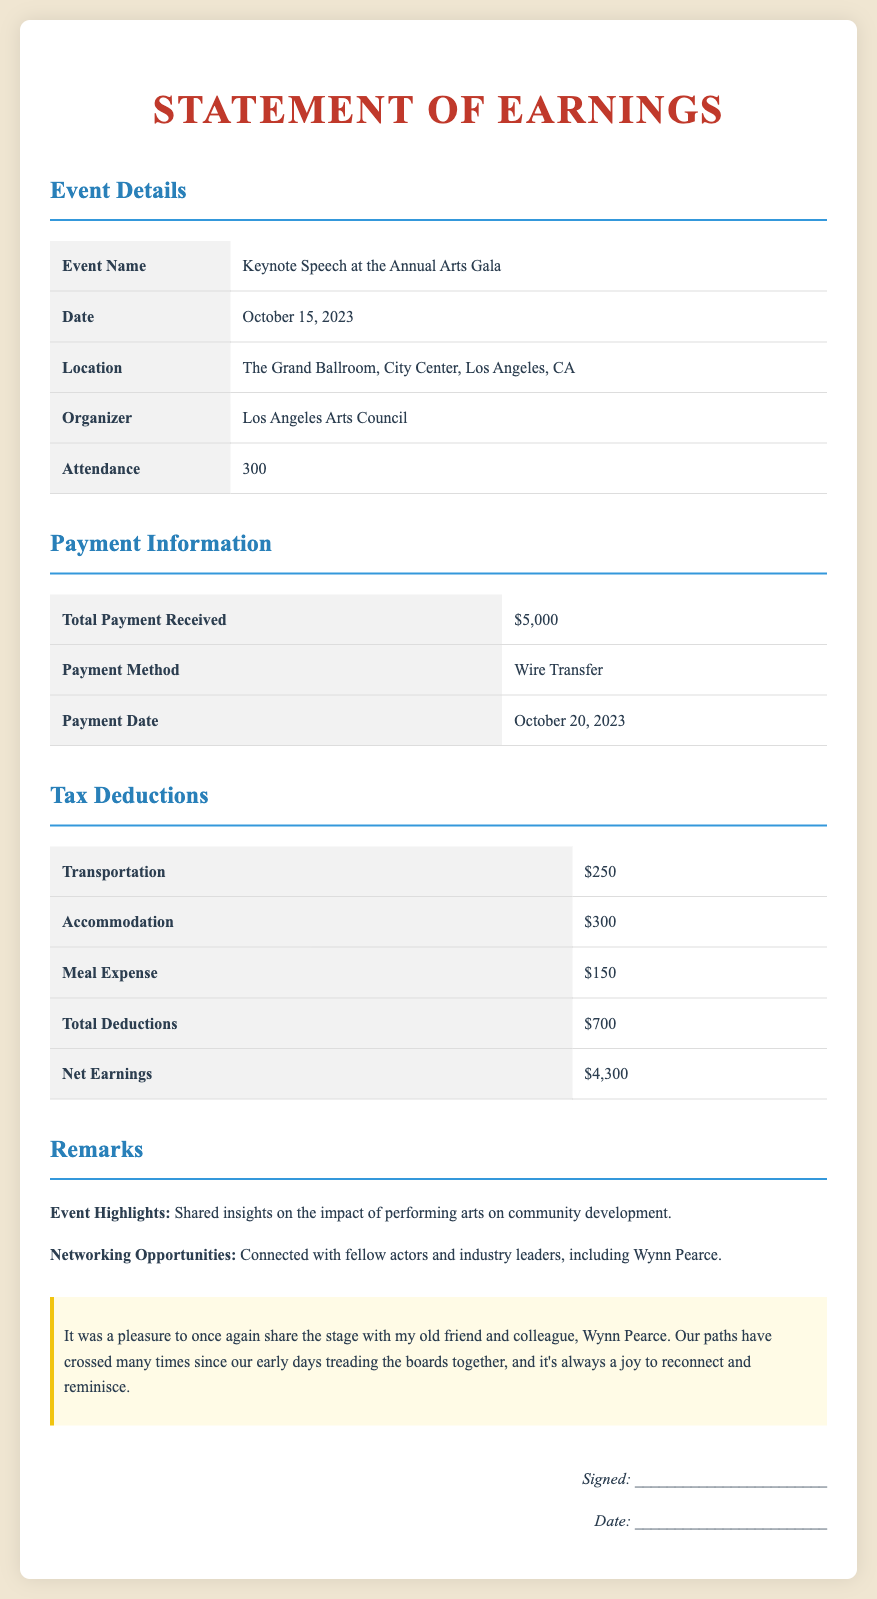what was the event name? The event name is clearly stated in the event details section of the document.
Answer: Keynote Speech at the Annual Arts Gala when did the event occur? The date of the event is provided in the event details section.
Answer: October 15, 2023 where was the event held? The location of the event is mentioned in the document under event details.
Answer: The Grand Ballroom, City Center, Los Angeles, CA what was the total payment received? The total payment received is specified in the payment information section.
Answer: $5,000 what were the total deductions? The total deductions are summarized in the tax deductions section of the document.
Answer: $700 what were the net earnings from the speaking engagement? The net earnings are calculated in the tax deductions section and are listed explicitly.
Answer: $4,300 how was the payment made? The method of payment is outlined in the payment information section.
Answer: Wire Transfer who was the organizer of the event? The organizer is clearly identified in the document under the event details section.
Answer: Los Angeles Arts Council what insights were shared during the event? The event highlights section summarizes the content of the keynote speech.
Answer: Impact of performing arts on community development 